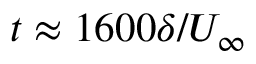<formula> <loc_0><loc_0><loc_500><loc_500>t \approx 1 6 0 0 \delta / U _ { \infty }</formula> 